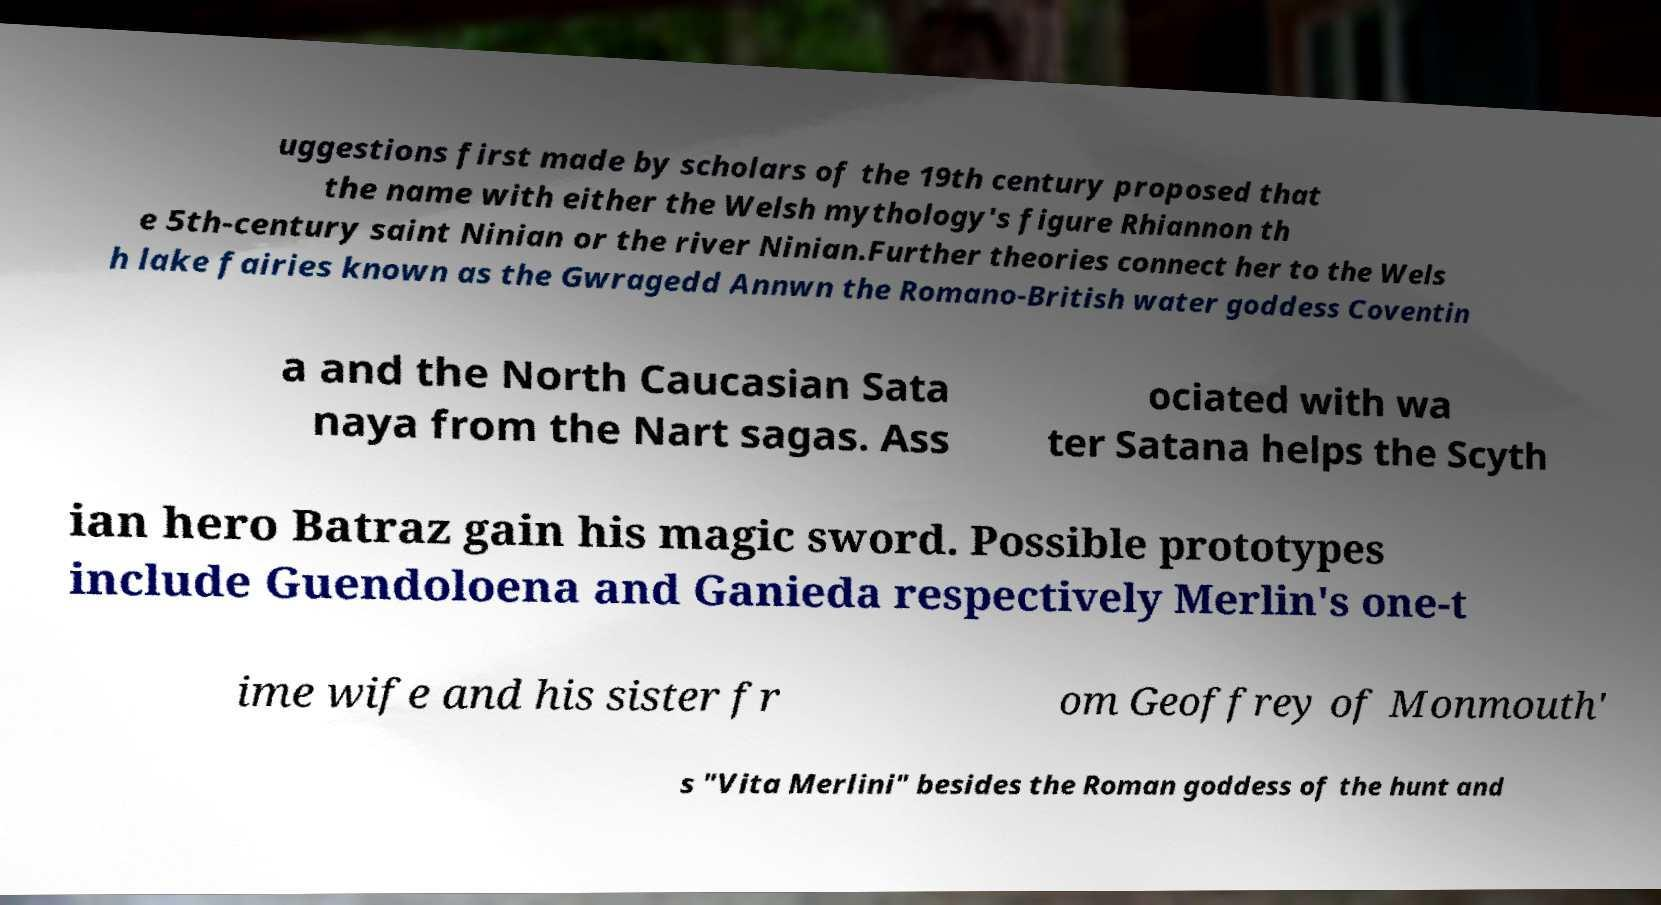What messages or text are displayed in this image? I need them in a readable, typed format. uggestions first made by scholars of the 19th century proposed that the name with either the Welsh mythology's figure Rhiannon th e 5th-century saint Ninian or the river Ninian.Further theories connect her to the Wels h lake fairies known as the Gwragedd Annwn the Romano-British water goddess Coventin a and the North Caucasian Sata naya from the Nart sagas. Ass ociated with wa ter Satana helps the Scyth ian hero Batraz gain his magic sword. Possible prototypes include Guendoloena and Ganieda respectively Merlin's one-t ime wife and his sister fr om Geoffrey of Monmouth' s "Vita Merlini" besides the Roman goddess of the hunt and 